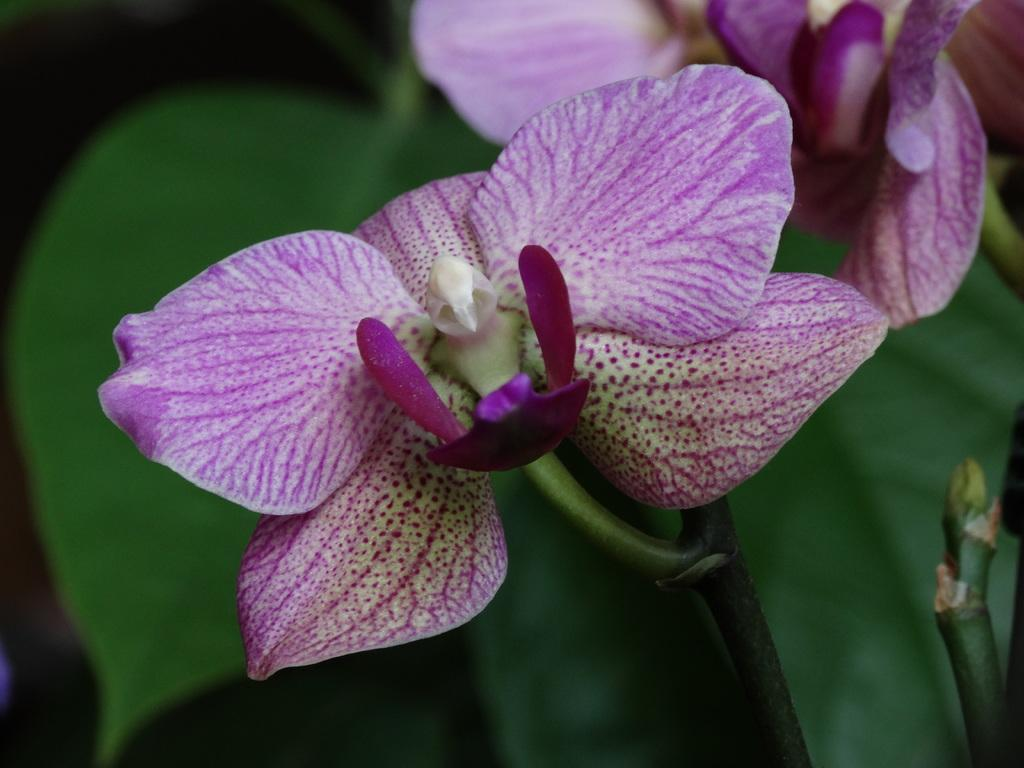What type of flora is present in the image? There are flowers in the image. What colors can be seen in the flowers? The flowers are pink and white in color. Are there any other parts of the plants visible in the image? Yes, there are leaves associated with the flowers. What is the color of the background in the image? The background of the image is dark. What is the owner's opinion about the flowers in the image? There is no information about an owner or their opinion in the image. 